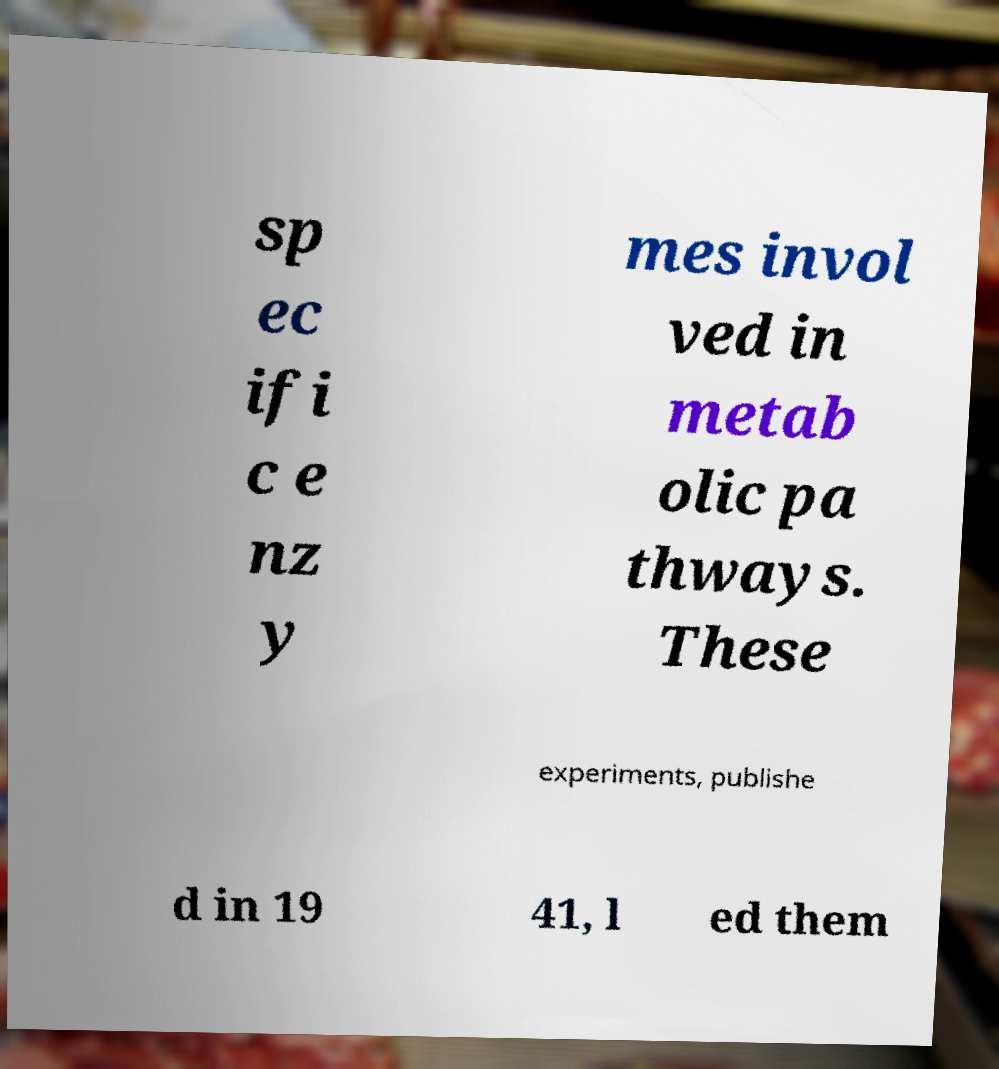Could you extract and type out the text from this image? sp ec ifi c e nz y mes invol ved in metab olic pa thways. These experiments, publishe d in 19 41, l ed them 